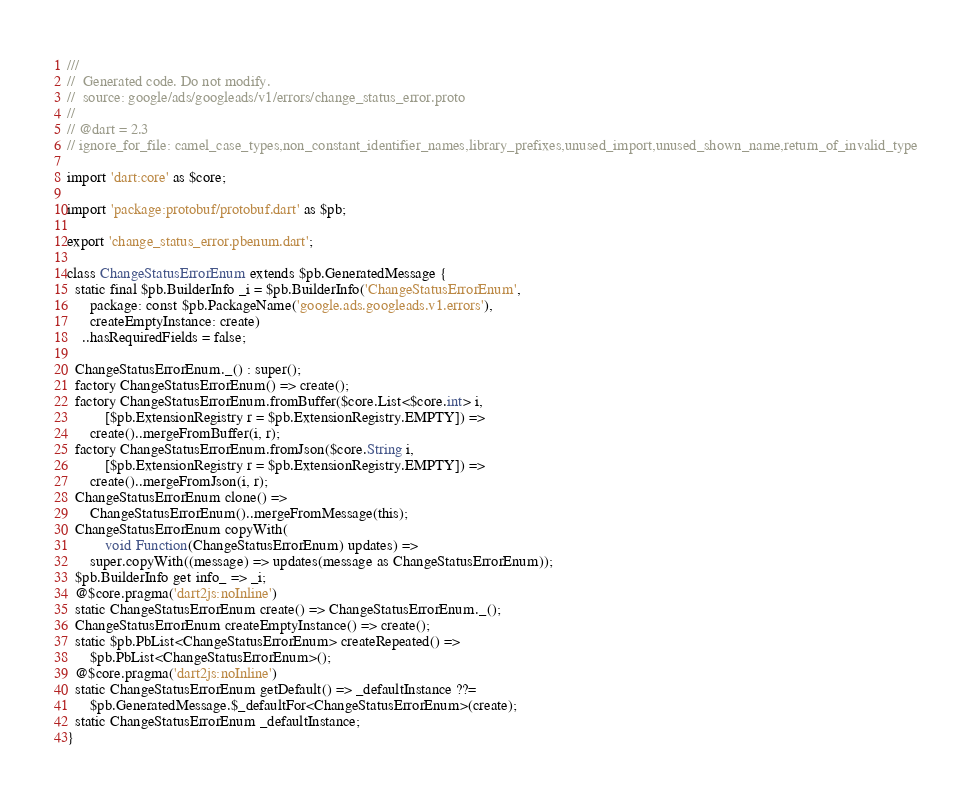<code> <loc_0><loc_0><loc_500><loc_500><_Dart_>///
//  Generated code. Do not modify.
//  source: google/ads/googleads/v1/errors/change_status_error.proto
//
// @dart = 2.3
// ignore_for_file: camel_case_types,non_constant_identifier_names,library_prefixes,unused_import,unused_shown_name,return_of_invalid_type

import 'dart:core' as $core;

import 'package:protobuf/protobuf.dart' as $pb;

export 'change_status_error.pbenum.dart';

class ChangeStatusErrorEnum extends $pb.GeneratedMessage {
  static final $pb.BuilderInfo _i = $pb.BuilderInfo('ChangeStatusErrorEnum',
      package: const $pb.PackageName('google.ads.googleads.v1.errors'),
      createEmptyInstance: create)
    ..hasRequiredFields = false;

  ChangeStatusErrorEnum._() : super();
  factory ChangeStatusErrorEnum() => create();
  factory ChangeStatusErrorEnum.fromBuffer($core.List<$core.int> i,
          [$pb.ExtensionRegistry r = $pb.ExtensionRegistry.EMPTY]) =>
      create()..mergeFromBuffer(i, r);
  factory ChangeStatusErrorEnum.fromJson($core.String i,
          [$pb.ExtensionRegistry r = $pb.ExtensionRegistry.EMPTY]) =>
      create()..mergeFromJson(i, r);
  ChangeStatusErrorEnum clone() =>
      ChangeStatusErrorEnum()..mergeFromMessage(this);
  ChangeStatusErrorEnum copyWith(
          void Function(ChangeStatusErrorEnum) updates) =>
      super.copyWith((message) => updates(message as ChangeStatusErrorEnum));
  $pb.BuilderInfo get info_ => _i;
  @$core.pragma('dart2js:noInline')
  static ChangeStatusErrorEnum create() => ChangeStatusErrorEnum._();
  ChangeStatusErrorEnum createEmptyInstance() => create();
  static $pb.PbList<ChangeStatusErrorEnum> createRepeated() =>
      $pb.PbList<ChangeStatusErrorEnum>();
  @$core.pragma('dart2js:noInline')
  static ChangeStatusErrorEnum getDefault() => _defaultInstance ??=
      $pb.GeneratedMessage.$_defaultFor<ChangeStatusErrorEnum>(create);
  static ChangeStatusErrorEnum _defaultInstance;
}
</code> 